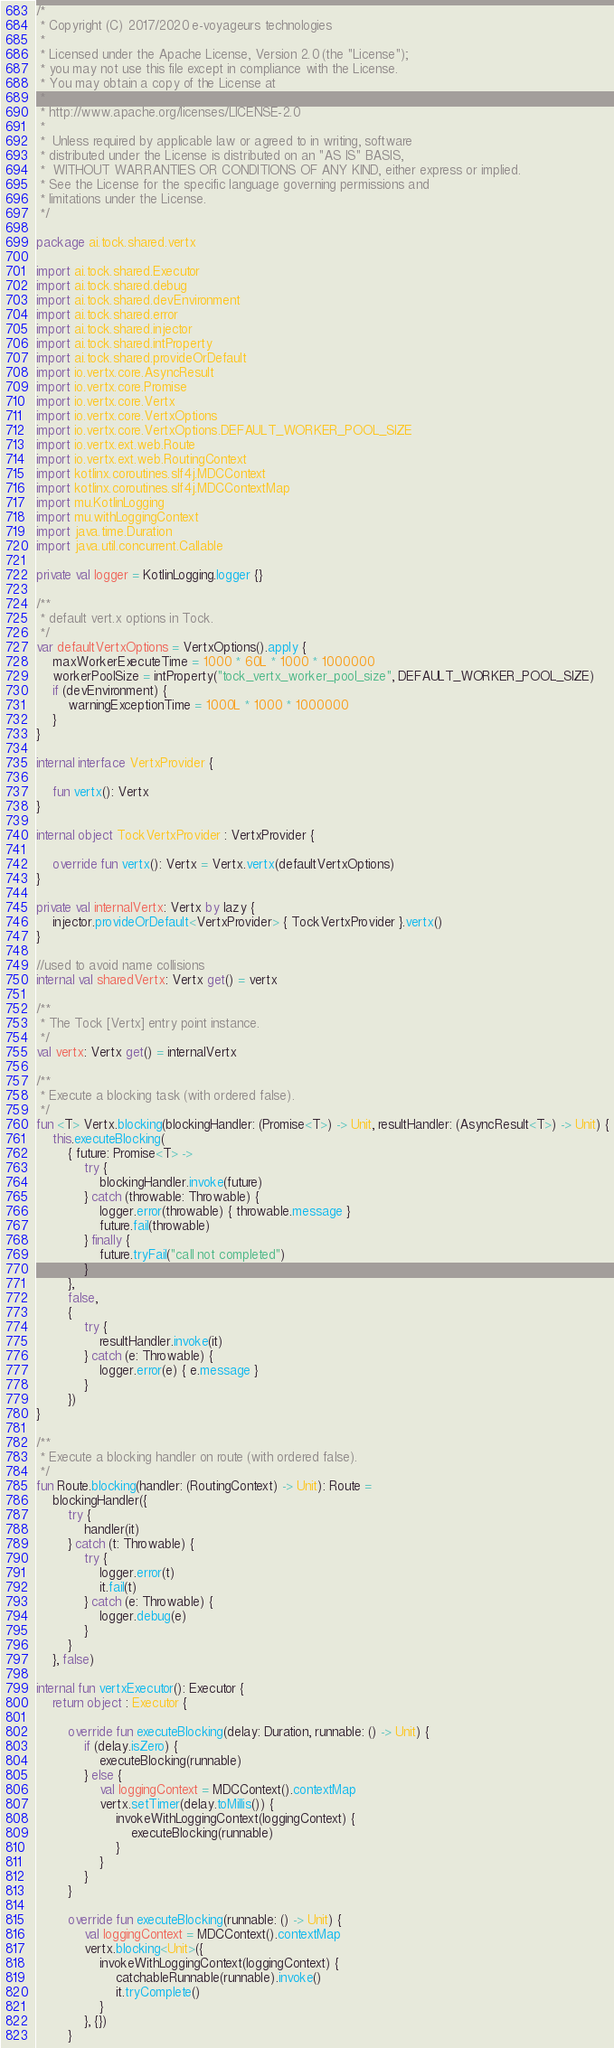Convert code to text. <code><loc_0><loc_0><loc_500><loc_500><_Kotlin_>/*
 * Copyright (C) 2017/2020 e-voyageurs technologies
 *
 * Licensed under the Apache License, Version 2.0 (the "License");
 * you may not use this file except in compliance with the License.
 * You may obtain a copy of the License at
 *
 * http://www.apache.org/licenses/LICENSE-2.0
 *
 *  Unless required by applicable law or agreed to in writing, software
 * distributed under the License is distributed on an "AS IS" BASIS,
 *  WITHOUT WARRANTIES OR CONDITIONS OF ANY KIND, either express or implied.
 * See the License for the specific language governing permissions and
 * limitations under the License.
 */

package ai.tock.shared.vertx

import ai.tock.shared.Executor
import ai.tock.shared.debug
import ai.tock.shared.devEnvironment
import ai.tock.shared.error
import ai.tock.shared.injector
import ai.tock.shared.intProperty
import ai.tock.shared.provideOrDefault
import io.vertx.core.AsyncResult
import io.vertx.core.Promise
import io.vertx.core.Vertx
import io.vertx.core.VertxOptions
import io.vertx.core.VertxOptions.DEFAULT_WORKER_POOL_SIZE
import io.vertx.ext.web.Route
import io.vertx.ext.web.RoutingContext
import kotlinx.coroutines.slf4j.MDCContext
import kotlinx.coroutines.slf4j.MDCContextMap
import mu.KotlinLogging
import mu.withLoggingContext
import java.time.Duration
import java.util.concurrent.Callable

private val logger = KotlinLogging.logger {}

/**
 * default vert.x options in Tock.
 */
var defaultVertxOptions = VertxOptions().apply {
    maxWorkerExecuteTime = 1000 * 60L * 1000 * 1000000
    workerPoolSize = intProperty("tock_vertx_worker_pool_size", DEFAULT_WORKER_POOL_SIZE)
    if (devEnvironment) {
        warningExceptionTime = 1000L * 1000 * 1000000
    }
}

internal interface VertxProvider {

    fun vertx(): Vertx
}

internal object TockVertxProvider : VertxProvider {

    override fun vertx(): Vertx = Vertx.vertx(defaultVertxOptions)
}

private val internalVertx: Vertx by lazy {
    injector.provideOrDefault<VertxProvider> { TockVertxProvider }.vertx()
}

//used to avoid name collisions
internal val sharedVertx: Vertx get() = vertx

/**
 * The Tock [Vertx] entry point instance.
 */
val vertx: Vertx get() = internalVertx

/**
 * Execute a blocking task (with ordered false).
 */
fun <T> Vertx.blocking(blockingHandler: (Promise<T>) -> Unit, resultHandler: (AsyncResult<T>) -> Unit) {
    this.executeBlocking(
        { future: Promise<T> ->
            try {
                blockingHandler.invoke(future)
            } catch (throwable: Throwable) {
                logger.error(throwable) { throwable.message }
                future.fail(throwable)
            } finally {
                future.tryFail("call not completed")
            }
        },
        false,
        {
            try {
                resultHandler.invoke(it)
            } catch (e: Throwable) {
                logger.error(e) { e.message }
            }
        })
}

/**
 * Execute a blocking handler on route (with ordered false).
 */
fun Route.blocking(handler: (RoutingContext) -> Unit): Route =
    blockingHandler({
        try {
            handler(it)
        } catch (t: Throwable) {
            try {
                logger.error(t)
                it.fail(t)
            } catch (e: Throwable) {
                logger.debug(e)
            }
        }
    }, false)

internal fun vertxExecutor(): Executor {
    return object : Executor {

        override fun executeBlocking(delay: Duration, runnable: () -> Unit) {
            if (delay.isZero) {
                executeBlocking(runnable)
            } else {
                val loggingContext = MDCContext().contextMap
                vertx.setTimer(delay.toMillis()) {
                    invokeWithLoggingContext(loggingContext) {
                        executeBlocking(runnable)
                    }
                }
            }
        }

        override fun executeBlocking(runnable: () -> Unit) {
            val loggingContext = MDCContext().contextMap
            vertx.blocking<Unit>({
                invokeWithLoggingContext(loggingContext) {
                    catchableRunnable(runnable).invoke()
                    it.tryComplete()
                }
            }, {})
        }
</code> 